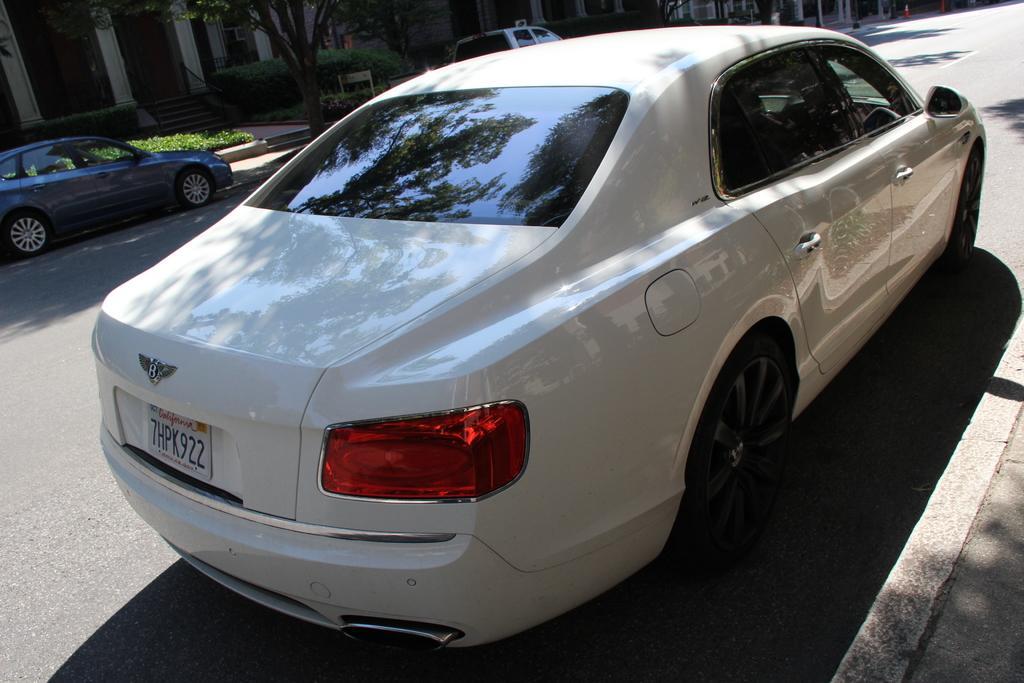How would you summarize this image in a sentence or two? At the bottom of the image there is a car on the road. Behind the car there are two cars on the ground. Behind them there is a footpath with small plants and also there are trees. There are houses with pillars, doors, steps and railings. 